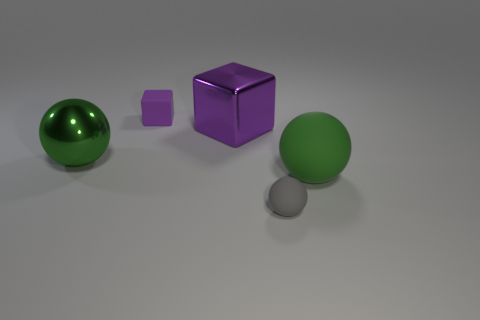Add 5 large yellow metallic things. How many objects exist? 10 Subtract all cubes. How many objects are left? 3 Subtract all large cyan matte spheres. Subtract all big purple objects. How many objects are left? 4 Add 2 purple things. How many purple things are left? 4 Add 4 tiny gray rubber objects. How many tiny gray rubber objects exist? 5 Subtract 0 blue spheres. How many objects are left? 5 